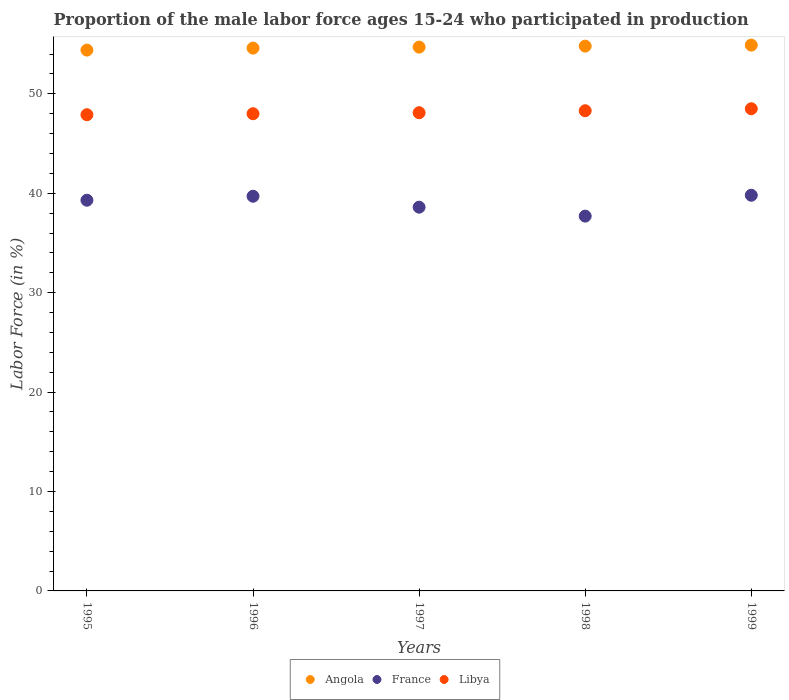What is the proportion of the male labor force who participated in production in Angola in 1996?
Ensure brevity in your answer.  54.6. Across all years, what is the maximum proportion of the male labor force who participated in production in France?
Offer a very short reply. 39.8. Across all years, what is the minimum proportion of the male labor force who participated in production in Libya?
Give a very brief answer. 47.9. In which year was the proportion of the male labor force who participated in production in France maximum?
Ensure brevity in your answer.  1999. What is the total proportion of the male labor force who participated in production in Libya in the graph?
Offer a terse response. 240.8. What is the difference between the proportion of the male labor force who participated in production in Angola in 1996 and that in 1999?
Give a very brief answer. -0.3. What is the difference between the proportion of the male labor force who participated in production in Libya in 1995 and the proportion of the male labor force who participated in production in France in 1997?
Your answer should be compact. 9.3. What is the average proportion of the male labor force who participated in production in France per year?
Offer a terse response. 39.02. In the year 1999, what is the difference between the proportion of the male labor force who participated in production in Angola and proportion of the male labor force who participated in production in Libya?
Give a very brief answer. 6.4. In how many years, is the proportion of the male labor force who participated in production in Angola greater than 40 %?
Keep it short and to the point. 5. What is the ratio of the proportion of the male labor force who participated in production in Angola in 1995 to that in 1999?
Offer a terse response. 0.99. Is the proportion of the male labor force who participated in production in France in 1995 less than that in 1999?
Offer a terse response. Yes. What is the difference between the highest and the second highest proportion of the male labor force who participated in production in Angola?
Your answer should be very brief. 0.1. What is the difference between the highest and the lowest proportion of the male labor force who participated in production in Libya?
Provide a succinct answer. 0.6. In how many years, is the proportion of the male labor force who participated in production in Angola greater than the average proportion of the male labor force who participated in production in Angola taken over all years?
Make the answer very short. 3. Does the proportion of the male labor force who participated in production in France monotonically increase over the years?
Give a very brief answer. No. Is the proportion of the male labor force who participated in production in France strictly greater than the proportion of the male labor force who participated in production in Angola over the years?
Make the answer very short. No. Is the proportion of the male labor force who participated in production in France strictly less than the proportion of the male labor force who participated in production in Angola over the years?
Offer a terse response. Yes. How many dotlines are there?
Your answer should be compact. 3. Does the graph contain any zero values?
Your answer should be compact. No. Where does the legend appear in the graph?
Offer a terse response. Bottom center. How many legend labels are there?
Your answer should be compact. 3. How are the legend labels stacked?
Provide a short and direct response. Horizontal. What is the title of the graph?
Your answer should be compact. Proportion of the male labor force ages 15-24 who participated in production. What is the label or title of the Y-axis?
Your answer should be compact. Labor Force (in %). What is the Labor Force (in %) in Angola in 1995?
Offer a terse response. 54.4. What is the Labor Force (in %) of France in 1995?
Provide a short and direct response. 39.3. What is the Labor Force (in %) in Libya in 1995?
Your response must be concise. 47.9. What is the Labor Force (in %) in Angola in 1996?
Provide a succinct answer. 54.6. What is the Labor Force (in %) of France in 1996?
Your answer should be very brief. 39.7. What is the Labor Force (in %) in Libya in 1996?
Offer a terse response. 48. What is the Labor Force (in %) in Angola in 1997?
Your response must be concise. 54.7. What is the Labor Force (in %) of France in 1997?
Your response must be concise. 38.6. What is the Labor Force (in %) of Libya in 1997?
Keep it short and to the point. 48.1. What is the Labor Force (in %) in Angola in 1998?
Make the answer very short. 54.8. What is the Labor Force (in %) of France in 1998?
Your answer should be very brief. 37.7. What is the Labor Force (in %) in Libya in 1998?
Keep it short and to the point. 48.3. What is the Labor Force (in %) in Angola in 1999?
Ensure brevity in your answer.  54.9. What is the Labor Force (in %) in France in 1999?
Offer a terse response. 39.8. What is the Labor Force (in %) of Libya in 1999?
Your response must be concise. 48.5. Across all years, what is the maximum Labor Force (in %) of Angola?
Provide a succinct answer. 54.9. Across all years, what is the maximum Labor Force (in %) in France?
Your answer should be compact. 39.8. Across all years, what is the maximum Labor Force (in %) in Libya?
Provide a succinct answer. 48.5. Across all years, what is the minimum Labor Force (in %) of Angola?
Give a very brief answer. 54.4. Across all years, what is the minimum Labor Force (in %) in France?
Keep it short and to the point. 37.7. Across all years, what is the minimum Labor Force (in %) of Libya?
Keep it short and to the point. 47.9. What is the total Labor Force (in %) in Angola in the graph?
Your answer should be compact. 273.4. What is the total Labor Force (in %) in France in the graph?
Your response must be concise. 195.1. What is the total Labor Force (in %) in Libya in the graph?
Your answer should be very brief. 240.8. What is the difference between the Labor Force (in %) in Angola in 1995 and that in 1996?
Ensure brevity in your answer.  -0.2. What is the difference between the Labor Force (in %) of France in 1995 and that in 1996?
Your answer should be very brief. -0.4. What is the difference between the Labor Force (in %) of Libya in 1995 and that in 1996?
Offer a terse response. -0.1. What is the difference between the Labor Force (in %) of Angola in 1995 and that in 1997?
Make the answer very short. -0.3. What is the difference between the Labor Force (in %) in Libya in 1995 and that in 1997?
Ensure brevity in your answer.  -0.2. What is the difference between the Labor Force (in %) in Angola in 1995 and that in 1998?
Your answer should be very brief. -0.4. What is the difference between the Labor Force (in %) of France in 1995 and that in 1998?
Ensure brevity in your answer.  1.6. What is the difference between the Labor Force (in %) of Libya in 1995 and that in 1998?
Offer a very short reply. -0.4. What is the difference between the Labor Force (in %) of Angola in 1995 and that in 1999?
Provide a short and direct response. -0.5. What is the difference between the Labor Force (in %) in France in 1995 and that in 1999?
Offer a terse response. -0.5. What is the difference between the Labor Force (in %) in Libya in 1995 and that in 1999?
Keep it short and to the point. -0.6. What is the difference between the Labor Force (in %) in France in 1996 and that in 1997?
Offer a very short reply. 1.1. What is the difference between the Labor Force (in %) of Libya in 1996 and that in 1997?
Give a very brief answer. -0.1. What is the difference between the Labor Force (in %) of Angola in 1996 and that in 1999?
Ensure brevity in your answer.  -0.3. What is the difference between the Labor Force (in %) of Libya in 1996 and that in 1999?
Your answer should be compact. -0.5. What is the difference between the Labor Force (in %) of Angola in 1997 and that in 1998?
Ensure brevity in your answer.  -0.1. What is the difference between the Labor Force (in %) in France in 1997 and that in 1998?
Ensure brevity in your answer.  0.9. What is the difference between the Labor Force (in %) of France in 1997 and that in 1999?
Provide a short and direct response. -1.2. What is the difference between the Labor Force (in %) of Libya in 1998 and that in 1999?
Provide a succinct answer. -0.2. What is the difference between the Labor Force (in %) of Angola in 1995 and the Labor Force (in %) of France in 1996?
Keep it short and to the point. 14.7. What is the difference between the Labor Force (in %) in France in 1995 and the Labor Force (in %) in Libya in 1996?
Offer a terse response. -8.7. What is the difference between the Labor Force (in %) in Angola in 1995 and the Labor Force (in %) in France in 1997?
Keep it short and to the point. 15.8. What is the difference between the Labor Force (in %) in Angola in 1995 and the Labor Force (in %) in Libya in 1997?
Keep it short and to the point. 6.3. What is the difference between the Labor Force (in %) in Angola in 1995 and the Labor Force (in %) in France in 1998?
Provide a succinct answer. 16.7. What is the difference between the Labor Force (in %) of Angola in 1996 and the Labor Force (in %) of France in 1997?
Provide a succinct answer. 16. What is the difference between the Labor Force (in %) of Angola in 1996 and the Labor Force (in %) of Libya in 1997?
Offer a terse response. 6.5. What is the difference between the Labor Force (in %) in France in 1996 and the Labor Force (in %) in Libya in 1997?
Give a very brief answer. -8.4. What is the difference between the Labor Force (in %) of Angola in 1996 and the Labor Force (in %) of France in 1998?
Offer a very short reply. 16.9. What is the difference between the Labor Force (in %) of France in 1996 and the Labor Force (in %) of Libya in 1998?
Provide a succinct answer. -8.6. What is the difference between the Labor Force (in %) in Angola in 1996 and the Labor Force (in %) in France in 1999?
Your response must be concise. 14.8. What is the difference between the Labor Force (in %) of France in 1996 and the Labor Force (in %) of Libya in 1999?
Keep it short and to the point. -8.8. What is the difference between the Labor Force (in %) of Angola in 1997 and the Labor Force (in %) of France in 1998?
Provide a short and direct response. 17. What is the difference between the Labor Force (in %) of Angola in 1997 and the Labor Force (in %) of Libya in 1999?
Offer a terse response. 6.2. What is the difference between the Labor Force (in %) in Angola in 1998 and the Labor Force (in %) in Libya in 1999?
Your response must be concise. 6.3. What is the average Labor Force (in %) in Angola per year?
Your answer should be compact. 54.68. What is the average Labor Force (in %) in France per year?
Offer a terse response. 39.02. What is the average Labor Force (in %) in Libya per year?
Make the answer very short. 48.16. In the year 1995, what is the difference between the Labor Force (in %) in Angola and Labor Force (in %) in Libya?
Provide a short and direct response. 6.5. In the year 1995, what is the difference between the Labor Force (in %) in France and Labor Force (in %) in Libya?
Ensure brevity in your answer.  -8.6. In the year 1996, what is the difference between the Labor Force (in %) of Angola and Labor Force (in %) of Libya?
Offer a very short reply. 6.6. In the year 1996, what is the difference between the Labor Force (in %) in France and Labor Force (in %) in Libya?
Keep it short and to the point. -8.3. In the year 1997, what is the difference between the Labor Force (in %) in Angola and Labor Force (in %) in France?
Ensure brevity in your answer.  16.1. In the year 1998, what is the difference between the Labor Force (in %) in France and Labor Force (in %) in Libya?
Make the answer very short. -10.6. In the year 1999, what is the difference between the Labor Force (in %) in Angola and Labor Force (in %) in France?
Ensure brevity in your answer.  15.1. In the year 1999, what is the difference between the Labor Force (in %) of Angola and Labor Force (in %) of Libya?
Keep it short and to the point. 6.4. What is the ratio of the Labor Force (in %) in Angola in 1995 to that in 1996?
Give a very brief answer. 1. What is the ratio of the Labor Force (in %) in France in 1995 to that in 1997?
Your response must be concise. 1.02. What is the ratio of the Labor Force (in %) of Angola in 1995 to that in 1998?
Keep it short and to the point. 0.99. What is the ratio of the Labor Force (in %) in France in 1995 to that in 1998?
Your response must be concise. 1.04. What is the ratio of the Labor Force (in %) in Libya in 1995 to that in 1998?
Provide a short and direct response. 0.99. What is the ratio of the Labor Force (in %) in Angola in 1995 to that in 1999?
Your response must be concise. 0.99. What is the ratio of the Labor Force (in %) of France in 1995 to that in 1999?
Ensure brevity in your answer.  0.99. What is the ratio of the Labor Force (in %) in Libya in 1995 to that in 1999?
Your answer should be compact. 0.99. What is the ratio of the Labor Force (in %) in France in 1996 to that in 1997?
Give a very brief answer. 1.03. What is the ratio of the Labor Force (in %) of Angola in 1996 to that in 1998?
Keep it short and to the point. 1. What is the ratio of the Labor Force (in %) in France in 1996 to that in 1998?
Your response must be concise. 1.05. What is the ratio of the Labor Force (in %) in France in 1996 to that in 1999?
Your response must be concise. 1. What is the ratio of the Labor Force (in %) in France in 1997 to that in 1998?
Provide a short and direct response. 1.02. What is the ratio of the Labor Force (in %) of France in 1997 to that in 1999?
Provide a succinct answer. 0.97. What is the ratio of the Labor Force (in %) in Libya in 1997 to that in 1999?
Your answer should be very brief. 0.99. What is the ratio of the Labor Force (in %) in Angola in 1998 to that in 1999?
Provide a succinct answer. 1. What is the ratio of the Labor Force (in %) in France in 1998 to that in 1999?
Offer a terse response. 0.95. What is the difference between the highest and the second highest Labor Force (in %) of France?
Provide a short and direct response. 0.1. What is the difference between the highest and the second highest Labor Force (in %) of Libya?
Give a very brief answer. 0.2. What is the difference between the highest and the lowest Labor Force (in %) of France?
Ensure brevity in your answer.  2.1. 